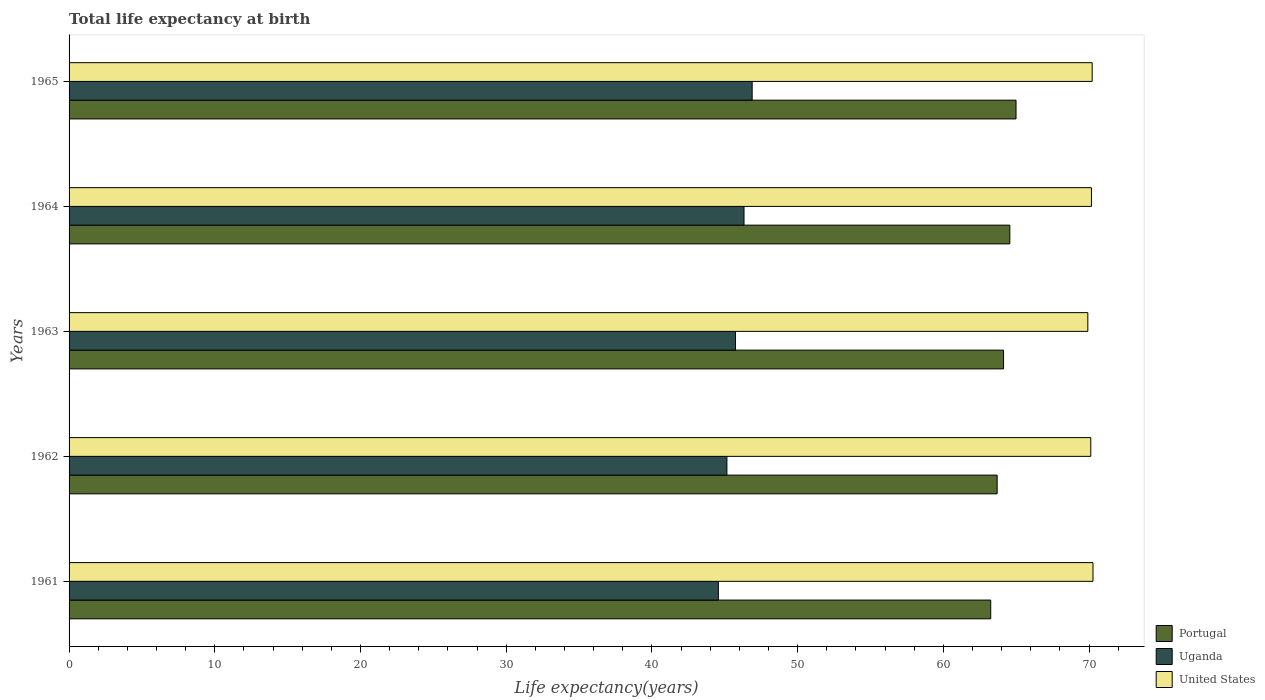How many different coloured bars are there?
Give a very brief answer. 3. What is the life expectancy at birth in in Uganda in 1963?
Provide a short and direct response. 45.74. Across all years, what is the maximum life expectancy at birth in in United States?
Give a very brief answer. 70.27. Across all years, what is the minimum life expectancy at birth in in Uganda?
Provide a short and direct response. 44.56. In which year was the life expectancy at birth in in Uganda maximum?
Your answer should be compact. 1965. What is the total life expectancy at birth in in United States in the graph?
Offer a terse response. 350.69. What is the difference between the life expectancy at birth in in United States in 1961 and that in 1964?
Make the answer very short. 0.1. What is the difference between the life expectancy at birth in in United States in 1962 and the life expectancy at birth in in Uganda in 1963?
Give a very brief answer. 24.38. What is the average life expectancy at birth in in Uganda per year?
Your answer should be compact. 45.73. In the year 1965, what is the difference between the life expectancy at birth in in United States and life expectancy at birth in in Uganda?
Your answer should be compact. 23.34. What is the ratio of the life expectancy at birth in in Uganda in 1961 to that in 1963?
Provide a succinct answer. 0.97. Is the difference between the life expectancy at birth in in United States in 1961 and 1963 greater than the difference between the life expectancy at birth in in Uganda in 1961 and 1963?
Keep it short and to the point. Yes. What is the difference between the highest and the second highest life expectancy at birth in in Uganda?
Provide a succinct answer. 0.56. What is the difference between the highest and the lowest life expectancy at birth in in Uganda?
Give a very brief answer. 2.32. What does the 1st bar from the bottom in 1962 represents?
Your answer should be compact. Portugal. How many bars are there?
Make the answer very short. 15. What is the difference between two consecutive major ticks on the X-axis?
Your answer should be very brief. 10. Are the values on the major ticks of X-axis written in scientific E-notation?
Offer a very short reply. No. Does the graph contain any zero values?
Provide a succinct answer. No. Where does the legend appear in the graph?
Provide a succinct answer. Bottom right. How many legend labels are there?
Give a very brief answer. 3. What is the title of the graph?
Offer a terse response. Total life expectancy at birth. Does "Venezuela" appear as one of the legend labels in the graph?
Offer a very short reply. No. What is the label or title of the X-axis?
Offer a terse response. Life expectancy(years). What is the label or title of the Y-axis?
Make the answer very short. Years. What is the Life expectancy(years) in Portugal in 1961?
Your response must be concise. 63.25. What is the Life expectancy(years) of Uganda in 1961?
Provide a short and direct response. 44.56. What is the Life expectancy(years) of United States in 1961?
Give a very brief answer. 70.27. What is the Life expectancy(years) in Portugal in 1962?
Keep it short and to the point. 63.69. What is the Life expectancy(years) in Uganda in 1962?
Keep it short and to the point. 45.15. What is the Life expectancy(years) in United States in 1962?
Keep it short and to the point. 70.12. What is the Life expectancy(years) of Portugal in 1963?
Your response must be concise. 64.13. What is the Life expectancy(years) of Uganda in 1963?
Your answer should be compact. 45.74. What is the Life expectancy(years) of United States in 1963?
Offer a terse response. 69.92. What is the Life expectancy(years) of Portugal in 1964?
Offer a terse response. 64.56. What is the Life expectancy(years) in Uganda in 1964?
Ensure brevity in your answer.  46.32. What is the Life expectancy(years) of United States in 1964?
Provide a short and direct response. 70.17. What is the Life expectancy(years) in Portugal in 1965?
Offer a terse response. 64.99. What is the Life expectancy(years) of Uganda in 1965?
Your answer should be very brief. 46.88. What is the Life expectancy(years) in United States in 1965?
Offer a very short reply. 70.21. Across all years, what is the maximum Life expectancy(years) in Portugal?
Make the answer very short. 64.99. Across all years, what is the maximum Life expectancy(years) of Uganda?
Offer a terse response. 46.88. Across all years, what is the maximum Life expectancy(years) in United States?
Make the answer very short. 70.27. Across all years, what is the minimum Life expectancy(years) in Portugal?
Offer a terse response. 63.25. Across all years, what is the minimum Life expectancy(years) in Uganda?
Give a very brief answer. 44.56. Across all years, what is the minimum Life expectancy(years) of United States?
Provide a short and direct response. 69.92. What is the total Life expectancy(years) of Portugal in the graph?
Keep it short and to the point. 320.63. What is the total Life expectancy(years) in Uganda in the graph?
Give a very brief answer. 228.65. What is the total Life expectancy(years) of United States in the graph?
Ensure brevity in your answer.  350.69. What is the difference between the Life expectancy(years) of Portugal in 1961 and that in 1962?
Give a very brief answer. -0.44. What is the difference between the Life expectancy(years) of Uganda in 1961 and that in 1962?
Give a very brief answer. -0.59. What is the difference between the Life expectancy(years) in United States in 1961 and that in 1962?
Your response must be concise. 0.15. What is the difference between the Life expectancy(years) of Portugal in 1961 and that in 1963?
Offer a very short reply. -0.88. What is the difference between the Life expectancy(years) in Uganda in 1961 and that in 1963?
Your answer should be very brief. -1.18. What is the difference between the Life expectancy(years) of United States in 1961 and that in 1963?
Provide a succinct answer. 0.35. What is the difference between the Life expectancy(years) of Portugal in 1961 and that in 1964?
Your response must be concise. -1.31. What is the difference between the Life expectancy(years) of Uganda in 1961 and that in 1964?
Keep it short and to the point. -1.76. What is the difference between the Life expectancy(years) of United States in 1961 and that in 1964?
Give a very brief answer. 0.1. What is the difference between the Life expectancy(years) in Portugal in 1961 and that in 1965?
Offer a very short reply. -1.74. What is the difference between the Life expectancy(years) in Uganda in 1961 and that in 1965?
Offer a very short reply. -2.32. What is the difference between the Life expectancy(years) of United States in 1961 and that in 1965?
Provide a short and direct response. 0.06. What is the difference between the Life expectancy(years) of Portugal in 1962 and that in 1963?
Ensure brevity in your answer.  -0.44. What is the difference between the Life expectancy(years) of Uganda in 1962 and that in 1963?
Ensure brevity in your answer.  -0.59. What is the difference between the Life expectancy(years) in United States in 1962 and that in 1963?
Your answer should be very brief. 0.2. What is the difference between the Life expectancy(years) in Portugal in 1962 and that in 1964?
Provide a succinct answer. -0.87. What is the difference between the Life expectancy(years) in Uganda in 1962 and that in 1964?
Ensure brevity in your answer.  -1.17. What is the difference between the Life expectancy(years) in United States in 1962 and that in 1964?
Provide a short and direct response. -0.05. What is the difference between the Life expectancy(years) of Portugal in 1962 and that in 1965?
Keep it short and to the point. -1.3. What is the difference between the Life expectancy(years) in Uganda in 1962 and that in 1965?
Make the answer very short. -1.73. What is the difference between the Life expectancy(years) of United States in 1962 and that in 1965?
Keep it short and to the point. -0.1. What is the difference between the Life expectancy(years) of Portugal in 1963 and that in 1964?
Give a very brief answer. -0.43. What is the difference between the Life expectancy(years) of Uganda in 1963 and that in 1964?
Your answer should be very brief. -0.58. What is the difference between the Life expectancy(years) of United States in 1963 and that in 1964?
Offer a very short reply. -0.25. What is the difference between the Life expectancy(years) of Portugal in 1963 and that in 1965?
Ensure brevity in your answer.  -0.86. What is the difference between the Life expectancy(years) of Uganda in 1963 and that in 1965?
Provide a short and direct response. -1.14. What is the difference between the Life expectancy(years) of United States in 1963 and that in 1965?
Ensure brevity in your answer.  -0.3. What is the difference between the Life expectancy(years) of Portugal in 1964 and that in 1965?
Your answer should be compact. -0.43. What is the difference between the Life expectancy(years) in Uganda in 1964 and that in 1965?
Make the answer very short. -0.56. What is the difference between the Life expectancy(years) of United States in 1964 and that in 1965?
Your answer should be compact. -0.05. What is the difference between the Life expectancy(years) of Portugal in 1961 and the Life expectancy(years) of Uganda in 1962?
Keep it short and to the point. 18.11. What is the difference between the Life expectancy(years) of Portugal in 1961 and the Life expectancy(years) of United States in 1962?
Ensure brevity in your answer.  -6.87. What is the difference between the Life expectancy(years) of Uganda in 1961 and the Life expectancy(years) of United States in 1962?
Ensure brevity in your answer.  -25.56. What is the difference between the Life expectancy(years) in Portugal in 1961 and the Life expectancy(years) in Uganda in 1963?
Offer a very short reply. 17.51. What is the difference between the Life expectancy(years) of Portugal in 1961 and the Life expectancy(years) of United States in 1963?
Your answer should be very brief. -6.66. What is the difference between the Life expectancy(years) in Uganda in 1961 and the Life expectancy(years) in United States in 1963?
Make the answer very short. -25.36. What is the difference between the Life expectancy(years) of Portugal in 1961 and the Life expectancy(years) of Uganda in 1964?
Make the answer very short. 16.93. What is the difference between the Life expectancy(years) of Portugal in 1961 and the Life expectancy(years) of United States in 1964?
Provide a succinct answer. -6.91. What is the difference between the Life expectancy(years) of Uganda in 1961 and the Life expectancy(years) of United States in 1964?
Ensure brevity in your answer.  -25.61. What is the difference between the Life expectancy(years) of Portugal in 1961 and the Life expectancy(years) of Uganda in 1965?
Keep it short and to the point. 16.37. What is the difference between the Life expectancy(years) of Portugal in 1961 and the Life expectancy(years) of United States in 1965?
Your answer should be very brief. -6.96. What is the difference between the Life expectancy(years) in Uganda in 1961 and the Life expectancy(years) in United States in 1965?
Your response must be concise. -25.65. What is the difference between the Life expectancy(years) of Portugal in 1962 and the Life expectancy(years) of Uganda in 1963?
Provide a succinct answer. 17.96. What is the difference between the Life expectancy(years) in Portugal in 1962 and the Life expectancy(years) in United States in 1963?
Keep it short and to the point. -6.22. What is the difference between the Life expectancy(years) in Uganda in 1962 and the Life expectancy(years) in United States in 1963?
Ensure brevity in your answer.  -24.77. What is the difference between the Life expectancy(years) of Portugal in 1962 and the Life expectancy(years) of Uganda in 1964?
Make the answer very short. 17.37. What is the difference between the Life expectancy(years) of Portugal in 1962 and the Life expectancy(years) of United States in 1964?
Ensure brevity in your answer.  -6.47. What is the difference between the Life expectancy(years) of Uganda in 1962 and the Life expectancy(years) of United States in 1964?
Your response must be concise. -25.02. What is the difference between the Life expectancy(years) of Portugal in 1962 and the Life expectancy(years) of Uganda in 1965?
Make the answer very short. 16.81. What is the difference between the Life expectancy(years) in Portugal in 1962 and the Life expectancy(years) in United States in 1965?
Give a very brief answer. -6.52. What is the difference between the Life expectancy(years) of Uganda in 1962 and the Life expectancy(years) of United States in 1965?
Provide a succinct answer. -25.07. What is the difference between the Life expectancy(years) of Portugal in 1963 and the Life expectancy(years) of Uganda in 1964?
Your answer should be very brief. 17.81. What is the difference between the Life expectancy(years) in Portugal in 1963 and the Life expectancy(years) in United States in 1964?
Your response must be concise. -6.03. What is the difference between the Life expectancy(years) of Uganda in 1963 and the Life expectancy(years) of United States in 1964?
Provide a short and direct response. -24.43. What is the difference between the Life expectancy(years) in Portugal in 1963 and the Life expectancy(years) in Uganda in 1965?
Give a very brief answer. 17.25. What is the difference between the Life expectancy(years) of Portugal in 1963 and the Life expectancy(years) of United States in 1965?
Your answer should be compact. -6.08. What is the difference between the Life expectancy(years) in Uganda in 1963 and the Life expectancy(years) in United States in 1965?
Your response must be concise. -24.48. What is the difference between the Life expectancy(years) of Portugal in 1964 and the Life expectancy(years) of Uganda in 1965?
Make the answer very short. 17.68. What is the difference between the Life expectancy(years) in Portugal in 1964 and the Life expectancy(years) in United States in 1965?
Provide a short and direct response. -5.65. What is the difference between the Life expectancy(years) of Uganda in 1964 and the Life expectancy(years) of United States in 1965?
Offer a terse response. -23.89. What is the average Life expectancy(years) in Portugal per year?
Provide a short and direct response. 64.13. What is the average Life expectancy(years) in Uganda per year?
Give a very brief answer. 45.73. What is the average Life expectancy(years) in United States per year?
Provide a succinct answer. 70.14. In the year 1961, what is the difference between the Life expectancy(years) in Portugal and Life expectancy(years) in Uganda?
Your response must be concise. 18.69. In the year 1961, what is the difference between the Life expectancy(years) in Portugal and Life expectancy(years) in United States?
Your response must be concise. -7.02. In the year 1961, what is the difference between the Life expectancy(years) in Uganda and Life expectancy(years) in United States?
Your answer should be very brief. -25.71. In the year 1962, what is the difference between the Life expectancy(years) of Portugal and Life expectancy(years) of Uganda?
Provide a succinct answer. 18.55. In the year 1962, what is the difference between the Life expectancy(years) in Portugal and Life expectancy(years) in United States?
Give a very brief answer. -6.43. In the year 1962, what is the difference between the Life expectancy(years) of Uganda and Life expectancy(years) of United States?
Your answer should be compact. -24.97. In the year 1963, what is the difference between the Life expectancy(years) of Portugal and Life expectancy(years) of Uganda?
Give a very brief answer. 18.39. In the year 1963, what is the difference between the Life expectancy(years) in Portugal and Life expectancy(years) in United States?
Provide a succinct answer. -5.78. In the year 1963, what is the difference between the Life expectancy(years) of Uganda and Life expectancy(years) of United States?
Provide a succinct answer. -24.18. In the year 1964, what is the difference between the Life expectancy(years) in Portugal and Life expectancy(years) in Uganda?
Offer a very short reply. 18.24. In the year 1964, what is the difference between the Life expectancy(years) in Portugal and Life expectancy(years) in United States?
Your answer should be compact. -5.6. In the year 1964, what is the difference between the Life expectancy(years) in Uganda and Life expectancy(years) in United States?
Keep it short and to the point. -23.84. In the year 1965, what is the difference between the Life expectancy(years) of Portugal and Life expectancy(years) of Uganda?
Offer a very short reply. 18.11. In the year 1965, what is the difference between the Life expectancy(years) in Portugal and Life expectancy(years) in United States?
Provide a short and direct response. -5.23. In the year 1965, what is the difference between the Life expectancy(years) of Uganda and Life expectancy(years) of United States?
Give a very brief answer. -23.34. What is the ratio of the Life expectancy(years) in Portugal in 1961 to that in 1962?
Your answer should be very brief. 0.99. What is the ratio of the Life expectancy(years) in United States in 1961 to that in 1962?
Give a very brief answer. 1. What is the ratio of the Life expectancy(years) of Portugal in 1961 to that in 1963?
Your answer should be compact. 0.99. What is the ratio of the Life expectancy(years) of Uganda in 1961 to that in 1963?
Ensure brevity in your answer.  0.97. What is the ratio of the Life expectancy(years) of United States in 1961 to that in 1963?
Offer a very short reply. 1.01. What is the ratio of the Life expectancy(years) of Portugal in 1961 to that in 1964?
Keep it short and to the point. 0.98. What is the ratio of the Life expectancy(years) of Portugal in 1961 to that in 1965?
Keep it short and to the point. 0.97. What is the ratio of the Life expectancy(years) of Uganda in 1961 to that in 1965?
Give a very brief answer. 0.95. What is the ratio of the Life expectancy(years) of United States in 1961 to that in 1965?
Your response must be concise. 1. What is the ratio of the Life expectancy(years) in Uganda in 1962 to that in 1963?
Provide a short and direct response. 0.99. What is the ratio of the Life expectancy(years) of United States in 1962 to that in 1963?
Give a very brief answer. 1. What is the ratio of the Life expectancy(years) of Portugal in 1962 to that in 1964?
Give a very brief answer. 0.99. What is the ratio of the Life expectancy(years) in Uganda in 1962 to that in 1964?
Provide a short and direct response. 0.97. What is the ratio of the Life expectancy(years) in United States in 1962 to that in 1964?
Keep it short and to the point. 1. What is the ratio of the Life expectancy(years) of Portugal in 1962 to that in 1965?
Offer a terse response. 0.98. What is the ratio of the Life expectancy(years) in Uganda in 1963 to that in 1964?
Provide a short and direct response. 0.99. What is the ratio of the Life expectancy(years) of Uganda in 1963 to that in 1965?
Ensure brevity in your answer.  0.98. What is the ratio of the Life expectancy(years) in United States in 1963 to that in 1965?
Your answer should be very brief. 1. What is the difference between the highest and the second highest Life expectancy(years) of Portugal?
Your answer should be very brief. 0.43. What is the difference between the highest and the second highest Life expectancy(years) in Uganda?
Provide a short and direct response. 0.56. What is the difference between the highest and the second highest Life expectancy(years) in United States?
Keep it short and to the point. 0.06. What is the difference between the highest and the lowest Life expectancy(years) of Portugal?
Your answer should be compact. 1.74. What is the difference between the highest and the lowest Life expectancy(years) in Uganda?
Give a very brief answer. 2.32. What is the difference between the highest and the lowest Life expectancy(years) of United States?
Provide a short and direct response. 0.35. 